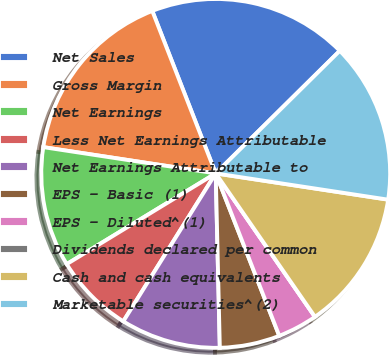<chart> <loc_0><loc_0><loc_500><loc_500><pie_chart><fcel>Net Sales<fcel>Gross Margin<fcel>Net Earnings<fcel>Less Net Earnings Attributable<fcel>Net Earnings Attributable to<fcel>EPS - Basic (1)<fcel>EPS - Diluted^(1)<fcel>Dividends declared per common<fcel>Cash and cash equivalents<fcel>Marketable securities^(2)<nl><fcel>18.52%<fcel>16.67%<fcel>11.11%<fcel>7.41%<fcel>9.26%<fcel>5.56%<fcel>3.7%<fcel>0.0%<fcel>12.96%<fcel>14.81%<nl></chart> 